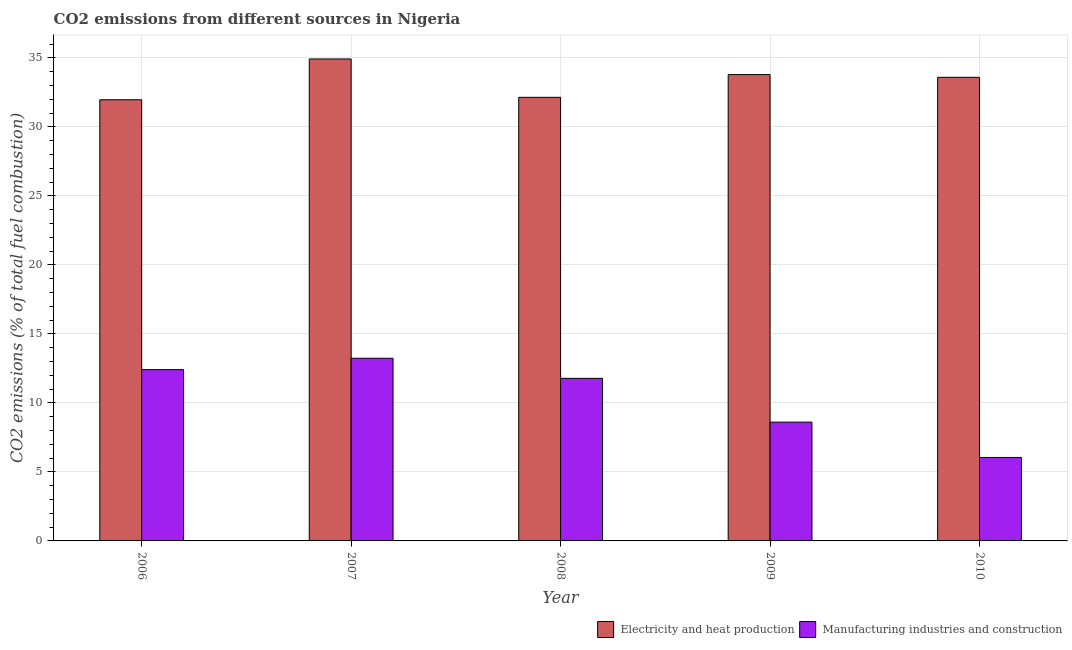How many different coloured bars are there?
Make the answer very short. 2. Are the number of bars per tick equal to the number of legend labels?
Provide a succinct answer. Yes. How many bars are there on the 5th tick from the left?
Provide a succinct answer. 2. What is the label of the 3rd group of bars from the left?
Provide a succinct answer. 2008. In how many cases, is the number of bars for a given year not equal to the number of legend labels?
Keep it short and to the point. 0. What is the co2 emissions due to manufacturing industries in 2010?
Keep it short and to the point. 6.05. Across all years, what is the maximum co2 emissions due to electricity and heat production?
Keep it short and to the point. 34.92. Across all years, what is the minimum co2 emissions due to electricity and heat production?
Provide a short and direct response. 31.97. In which year was the co2 emissions due to electricity and heat production maximum?
Make the answer very short. 2007. In which year was the co2 emissions due to electricity and heat production minimum?
Your answer should be compact. 2006. What is the total co2 emissions due to electricity and heat production in the graph?
Your response must be concise. 166.42. What is the difference between the co2 emissions due to electricity and heat production in 2009 and that in 2010?
Your answer should be very brief. 0.2. What is the difference between the co2 emissions due to manufacturing industries in 2010 and the co2 emissions due to electricity and heat production in 2009?
Offer a very short reply. -2.56. What is the average co2 emissions due to electricity and heat production per year?
Your response must be concise. 33.28. In the year 2006, what is the difference between the co2 emissions due to electricity and heat production and co2 emissions due to manufacturing industries?
Your response must be concise. 0. In how many years, is the co2 emissions due to electricity and heat production greater than 12 %?
Your answer should be compact. 5. What is the ratio of the co2 emissions due to manufacturing industries in 2007 to that in 2009?
Your response must be concise. 1.54. Is the co2 emissions due to manufacturing industries in 2007 less than that in 2009?
Give a very brief answer. No. Is the difference between the co2 emissions due to electricity and heat production in 2008 and 2009 greater than the difference between the co2 emissions due to manufacturing industries in 2008 and 2009?
Make the answer very short. No. What is the difference between the highest and the second highest co2 emissions due to manufacturing industries?
Make the answer very short. 0.83. What is the difference between the highest and the lowest co2 emissions due to electricity and heat production?
Your response must be concise. 2.96. Is the sum of the co2 emissions due to manufacturing industries in 2006 and 2007 greater than the maximum co2 emissions due to electricity and heat production across all years?
Your response must be concise. Yes. What does the 1st bar from the left in 2009 represents?
Provide a succinct answer. Electricity and heat production. What does the 2nd bar from the right in 2006 represents?
Keep it short and to the point. Electricity and heat production. How many bars are there?
Make the answer very short. 10. What is the difference between two consecutive major ticks on the Y-axis?
Your response must be concise. 5. Does the graph contain any zero values?
Ensure brevity in your answer.  No. Does the graph contain grids?
Offer a very short reply. Yes. How many legend labels are there?
Your response must be concise. 2. What is the title of the graph?
Make the answer very short. CO2 emissions from different sources in Nigeria. Does "Travel Items" appear as one of the legend labels in the graph?
Keep it short and to the point. No. What is the label or title of the Y-axis?
Ensure brevity in your answer.  CO2 emissions (% of total fuel combustion). What is the CO2 emissions (% of total fuel combustion) in Electricity and heat production in 2006?
Ensure brevity in your answer.  31.97. What is the CO2 emissions (% of total fuel combustion) in Manufacturing industries and construction in 2006?
Make the answer very short. 12.41. What is the CO2 emissions (% of total fuel combustion) of Electricity and heat production in 2007?
Your response must be concise. 34.92. What is the CO2 emissions (% of total fuel combustion) in Manufacturing industries and construction in 2007?
Offer a terse response. 13.24. What is the CO2 emissions (% of total fuel combustion) of Electricity and heat production in 2008?
Your answer should be compact. 32.14. What is the CO2 emissions (% of total fuel combustion) in Manufacturing industries and construction in 2008?
Make the answer very short. 11.78. What is the CO2 emissions (% of total fuel combustion) in Electricity and heat production in 2009?
Provide a short and direct response. 33.79. What is the CO2 emissions (% of total fuel combustion) of Manufacturing industries and construction in 2009?
Keep it short and to the point. 8.61. What is the CO2 emissions (% of total fuel combustion) in Electricity and heat production in 2010?
Offer a very short reply. 33.59. What is the CO2 emissions (% of total fuel combustion) in Manufacturing industries and construction in 2010?
Ensure brevity in your answer.  6.05. Across all years, what is the maximum CO2 emissions (% of total fuel combustion) in Electricity and heat production?
Keep it short and to the point. 34.92. Across all years, what is the maximum CO2 emissions (% of total fuel combustion) in Manufacturing industries and construction?
Your answer should be very brief. 13.24. Across all years, what is the minimum CO2 emissions (% of total fuel combustion) in Electricity and heat production?
Provide a succinct answer. 31.97. Across all years, what is the minimum CO2 emissions (% of total fuel combustion) in Manufacturing industries and construction?
Your answer should be compact. 6.05. What is the total CO2 emissions (% of total fuel combustion) in Electricity and heat production in the graph?
Provide a succinct answer. 166.42. What is the total CO2 emissions (% of total fuel combustion) in Manufacturing industries and construction in the graph?
Offer a very short reply. 52.09. What is the difference between the CO2 emissions (% of total fuel combustion) in Electricity and heat production in 2006 and that in 2007?
Make the answer very short. -2.96. What is the difference between the CO2 emissions (% of total fuel combustion) of Manufacturing industries and construction in 2006 and that in 2007?
Offer a very short reply. -0.83. What is the difference between the CO2 emissions (% of total fuel combustion) in Electricity and heat production in 2006 and that in 2008?
Your answer should be very brief. -0.18. What is the difference between the CO2 emissions (% of total fuel combustion) in Manufacturing industries and construction in 2006 and that in 2008?
Your answer should be compact. 0.63. What is the difference between the CO2 emissions (% of total fuel combustion) of Electricity and heat production in 2006 and that in 2009?
Your answer should be compact. -1.82. What is the difference between the CO2 emissions (% of total fuel combustion) of Manufacturing industries and construction in 2006 and that in 2009?
Give a very brief answer. 3.8. What is the difference between the CO2 emissions (% of total fuel combustion) in Electricity and heat production in 2006 and that in 2010?
Your answer should be compact. -1.63. What is the difference between the CO2 emissions (% of total fuel combustion) of Manufacturing industries and construction in 2006 and that in 2010?
Keep it short and to the point. 6.36. What is the difference between the CO2 emissions (% of total fuel combustion) of Electricity and heat production in 2007 and that in 2008?
Provide a short and direct response. 2.78. What is the difference between the CO2 emissions (% of total fuel combustion) in Manufacturing industries and construction in 2007 and that in 2008?
Your response must be concise. 1.46. What is the difference between the CO2 emissions (% of total fuel combustion) of Electricity and heat production in 2007 and that in 2009?
Keep it short and to the point. 1.13. What is the difference between the CO2 emissions (% of total fuel combustion) in Manufacturing industries and construction in 2007 and that in 2009?
Offer a terse response. 4.63. What is the difference between the CO2 emissions (% of total fuel combustion) of Electricity and heat production in 2007 and that in 2010?
Give a very brief answer. 1.33. What is the difference between the CO2 emissions (% of total fuel combustion) in Manufacturing industries and construction in 2007 and that in 2010?
Keep it short and to the point. 7.19. What is the difference between the CO2 emissions (% of total fuel combustion) in Electricity and heat production in 2008 and that in 2009?
Your answer should be compact. -1.65. What is the difference between the CO2 emissions (% of total fuel combustion) in Manufacturing industries and construction in 2008 and that in 2009?
Your answer should be very brief. 3.17. What is the difference between the CO2 emissions (% of total fuel combustion) in Electricity and heat production in 2008 and that in 2010?
Your answer should be compact. -1.45. What is the difference between the CO2 emissions (% of total fuel combustion) of Manufacturing industries and construction in 2008 and that in 2010?
Keep it short and to the point. 5.73. What is the difference between the CO2 emissions (% of total fuel combustion) in Electricity and heat production in 2009 and that in 2010?
Your answer should be very brief. 0.2. What is the difference between the CO2 emissions (% of total fuel combustion) in Manufacturing industries and construction in 2009 and that in 2010?
Provide a short and direct response. 2.56. What is the difference between the CO2 emissions (% of total fuel combustion) in Electricity and heat production in 2006 and the CO2 emissions (% of total fuel combustion) in Manufacturing industries and construction in 2007?
Your answer should be very brief. 18.73. What is the difference between the CO2 emissions (% of total fuel combustion) of Electricity and heat production in 2006 and the CO2 emissions (% of total fuel combustion) of Manufacturing industries and construction in 2008?
Provide a succinct answer. 20.19. What is the difference between the CO2 emissions (% of total fuel combustion) in Electricity and heat production in 2006 and the CO2 emissions (% of total fuel combustion) in Manufacturing industries and construction in 2009?
Provide a short and direct response. 23.36. What is the difference between the CO2 emissions (% of total fuel combustion) in Electricity and heat production in 2006 and the CO2 emissions (% of total fuel combustion) in Manufacturing industries and construction in 2010?
Keep it short and to the point. 25.92. What is the difference between the CO2 emissions (% of total fuel combustion) of Electricity and heat production in 2007 and the CO2 emissions (% of total fuel combustion) of Manufacturing industries and construction in 2008?
Keep it short and to the point. 23.14. What is the difference between the CO2 emissions (% of total fuel combustion) of Electricity and heat production in 2007 and the CO2 emissions (% of total fuel combustion) of Manufacturing industries and construction in 2009?
Offer a terse response. 26.31. What is the difference between the CO2 emissions (% of total fuel combustion) in Electricity and heat production in 2007 and the CO2 emissions (% of total fuel combustion) in Manufacturing industries and construction in 2010?
Your answer should be compact. 28.87. What is the difference between the CO2 emissions (% of total fuel combustion) in Electricity and heat production in 2008 and the CO2 emissions (% of total fuel combustion) in Manufacturing industries and construction in 2009?
Your answer should be very brief. 23.53. What is the difference between the CO2 emissions (% of total fuel combustion) in Electricity and heat production in 2008 and the CO2 emissions (% of total fuel combustion) in Manufacturing industries and construction in 2010?
Your answer should be very brief. 26.09. What is the difference between the CO2 emissions (% of total fuel combustion) in Electricity and heat production in 2009 and the CO2 emissions (% of total fuel combustion) in Manufacturing industries and construction in 2010?
Your answer should be very brief. 27.74. What is the average CO2 emissions (% of total fuel combustion) of Electricity and heat production per year?
Ensure brevity in your answer.  33.28. What is the average CO2 emissions (% of total fuel combustion) of Manufacturing industries and construction per year?
Your response must be concise. 10.42. In the year 2006, what is the difference between the CO2 emissions (% of total fuel combustion) in Electricity and heat production and CO2 emissions (% of total fuel combustion) in Manufacturing industries and construction?
Offer a terse response. 19.56. In the year 2007, what is the difference between the CO2 emissions (% of total fuel combustion) of Electricity and heat production and CO2 emissions (% of total fuel combustion) of Manufacturing industries and construction?
Offer a terse response. 21.69. In the year 2008, what is the difference between the CO2 emissions (% of total fuel combustion) of Electricity and heat production and CO2 emissions (% of total fuel combustion) of Manufacturing industries and construction?
Offer a terse response. 20.36. In the year 2009, what is the difference between the CO2 emissions (% of total fuel combustion) in Electricity and heat production and CO2 emissions (% of total fuel combustion) in Manufacturing industries and construction?
Offer a very short reply. 25.18. In the year 2010, what is the difference between the CO2 emissions (% of total fuel combustion) of Electricity and heat production and CO2 emissions (% of total fuel combustion) of Manufacturing industries and construction?
Ensure brevity in your answer.  27.55. What is the ratio of the CO2 emissions (% of total fuel combustion) in Electricity and heat production in 2006 to that in 2007?
Offer a terse response. 0.92. What is the ratio of the CO2 emissions (% of total fuel combustion) of Manufacturing industries and construction in 2006 to that in 2007?
Your response must be concise. 0.94. What is the ratio of the CO2 emissions (% of total fuel combustion) in Manufacturing industries and construction in 2006 to that in 2008?
Give a very brief answer. 1.05. What is the ratio of the CO2 emissions (% of total fuel combustion) in Electricity and heat production in 2006 to that in 2009?
Provide a succinct answer. 0.95. What is the ratio of the CO2 emissions (% of total fuel combustion) in Manufacturing industries and construction in 2006 to that in 2009?
Your answer should be very brief. 1.44. What is the ratio of the CO2 emissions (% of total fuel combustion) of Electricity and heat production in 2006 to that in 2010?
Your response must be concise. 0.95. What is the ratio of the CO2 emissions (% of total fuel combustion) in Manufacturing industries and construction in 2006 to that in 2010?
Your answer should be compact. 2.05. What is the ratio of the CO2 emissions (% of total fuel combustion) of Electricity and heat production in 2007 to that in 2008?
Offer a very short reply. 1.09. What is the ratio of the CO2 emissions (% of total fuel combustion) in Manufacturing industries and construction in 2007 to that in 2008?
Keep it short and to the point. 1.12. What is the ratio of the CO2 emissions (% of total fuel combustion) of Electricity and heat production in 2007 to that in 2009?
Provide a short and direct response. 1.03. What is the ratio of the CO2 emissions (% of total fuel combustion) of Manufacturing industries and construction in 2007 to that in 2009?
Offer a very short reply. 1.54. What is the ratio of the CO2 emissions (% of total fuel combustion) of Electricity and heat production in 2007 to that in 2010?
Make the answer very short. 1.04. What is the ratio of the CO2 emissions (% of total fuel combustion) of Manufacturing industries and construction in 2007 to that in 2010?
Provide a short and direct response. 2.19. What is the ratio of the CO2 emissions (% of total fuel combustion) of Electricity and heat production in 2008 to that in 2009?
Provide a short and direct response. 0.95. What is the ratio of the CO2 emissions (% of total fuel combustion) of Manufacturing industries and construction in 2008 to that in 2009?
Provide a short and direct response. 1.37. What is the ratio of the CO2 emissions (% of total fuel combustion) in Electricity and heat production in 2008 to that in 2010?
Give a very brief answer. 0.96. What is the ratio of the CO2 emissions (% of total fuel combustion) of Manufacturing industries and construction in 2008 to that in 2010?
Offer a very short reply. 1.95. What is the ratio of the CO2 emissions (% of total fuel combustion) of Electricity and heat production in 2009 to that in 2010?
Offer a terse response. 1.01. What is the ratio of the CO2 emissions (% of total fuel combustion) of Manufacturing industries and construction in 2009 to that in 2010?
Offer a terse response. 1.42. What is the difference between the highest and the second highest CO2 emissions (% of total fuel combustion) in Electricity and heat production?
Provide a short and direct response. 1.13. What is the difference between the highest and the second highest CO2 emissions (% of total fuel combustion) of Manufacturing industries and construction?
Make the answer very short. 0.83. What is the difference between the highest and the lowest CO2 emissions (% of total fuel combustion) in Electricity and heat production?
Offer a very short reply. 2.96. What is the difference between the highest and the lowest CO2 emissions (% of total fuel combustion) in Manufacturing industries and construction?
Give a very brief answer. 7.19. 